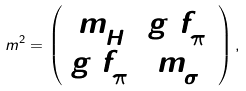<formula> <loc_0><loc_0><loc_500><loc_500>m ^ { 2 } = \left ( \begin{array} { c c } m _ { H } ^ { 2 } & g _ { 1 } f ^ { 2 } _ { \pi } \\ g _ { 1 } f ^ { 2 } _ { \pi } & m ^ { 2 } _ { \sigma } \end{array} \right ) ,</formula> 